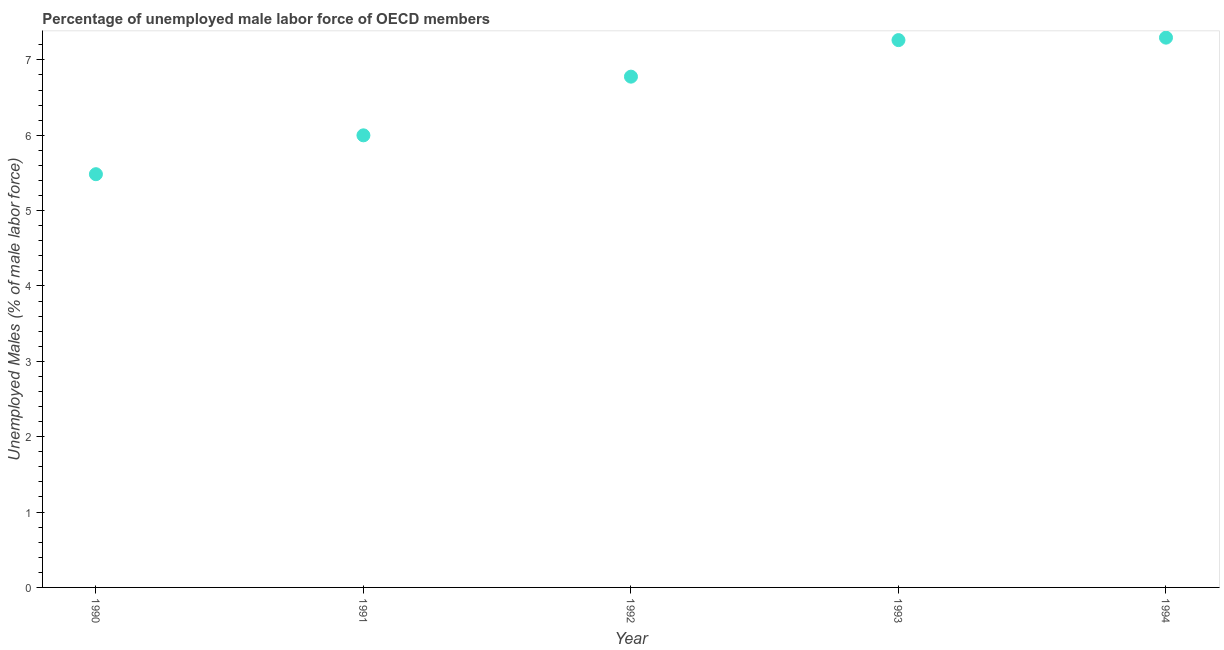What is the total unemployed male labour force in 1992?
Make the answer very short. 6.78. Across all years, what is the maximum total unemployed male labour force?
Offer a very short reply. 7.3. Across all years, what is the minimum total unemployed male labour force?
Provide a short and direct response. 5.48. In which year was the total unemployed male labour force maximum?
Your response must be concise. 1994. What is the sum of the total unemployed male labour force?
Ensure brevity in your answer.  32.82. What is the difference between the total unemployed male labour force in 1991 and 1992?
Keep it short and to the point. -0.78. What is the average total unemployed male labour force per year?
Keep it short and to the point. 6.56. What is the median total unemployed male labour force?
Your answer should be compact. 6.78. In how many years, is the total unemployed male labour force greater than 1 %?
Your response must be concise. 5. What is the ratio of the total unemployed male labour force in 1993 to that in 1994?
Give a very brief answer. 1. Is the total unemployed male labour force in 1992 less than that in 1993?
Provide a succinct answer. Yes. What is the difference between the highest and the second highest total unemployed male labour force?
Keep it short and to the point. 0.03. What is the difference between the highest and the lowest total unemployed male labour force?
Ensure brevity in your answer.  1.81. In how many years, is the total unemployed male labour force greater than the average total unemployed male labour force taken over all years?
Offer a terse response. 3. Does the total unemployed male labour force monotonically increase over the years?
Your answer should be compact. Yes. What is the difference between two consecutive major ticks on the Y-axis?
Keep it short and to the point. 1. What is the title of the graph?
Provide a succinct answer. Percentage of unemployed male labor force of OECD members. What is the label or title of the X-axis?
Your answer should be very brief. Year. What is the label or title of the Y-axis?
Your answer should be compact. Unemployed Males (% of male labor force). What is the Unemployed Males (% of male labor force) in 1990?
Your answer should be very brief. 5.48. What is the Unemployed Males (% of male labor force) in 1991?
Keep it short and to the point. 6. What is the Unemployed Males (% of male labor force) in 1992?
Keep it short and to the point. 6.78. What is the Unemployed Males (% of male labor force) in 1993?
Offer a terse response. 7.26. What is the Unemployed Males (% of male labor force) in 1994?
Ensure brevity in your answer.  7.3. What is the difference between the Unemployed Males (% of male labor force) in 1990 and 1991?
Provide a succinct answer. -0.52. What is the difference between the Unemployed Males (% of male labor force) in 1990 and 1992?
Your answer should be compact. -1.29. What is the difference between the Unemployed Males (% of male labor force) in 1990 and 1993?
Make the answer very short. -1.78. What is the difference between the Unemployed Males (% of male labor force) in 1990 and 1994?
Keep it short and to the point. -1.81. What is the difference between the Unemployed Males (% of male labor force) in 1991 and 1992?
Offer a very short reply. -0.78. What is the difference between the Unemployed Males (% of male labor force) in 1991 and 1993?
Give a very brief answer. -1.26. What is the difference between the Unemployed Males (% of male labor force) in 1991 and 1994?
Your answer should be very brief. -1.3. What is the difference between the Unemployed Males (% of male labor force) in 1992 and 1993?
Ensure brevity in your answer.  -0.48. What is the difference between the Unemployed Males (% of male labor force) in 1992 and 1994?
Your answer should be compact. -0.52. What is the difference between the Unemployed Males (% of male labor force) in 1993 and 1994?
Offer a terse response. -0.03. What is the ratio of the Unemployed Males (% of male labor force) in 1990 to that in 1991?
Your answer should be compact. 0.91. What is the ratio of the Unemployed Males (% of male labor force) in 1990 to that in 1992?
Offer a very short reply. 0.81. What is the ratio of the Unemployed Males (% of male labor force) in 1990 to that in 1993?
Your response must be concise. 0.76. What is the ratio of the Unemployed Males (% of male labor force) in 1990 to that in 1994?
Provide a succinct answer. 0.75. What is the ratio of the Unemployed Males (% of male labor force) in 1991 to that in 1992?
Offer a terse response. 0.89. What is the ratio of the Unemployed Males (% of male labor force) in 1991 to that in 1993?
Your answer should be compact. 0.83. What is the ratio of the Unemployed Males (% of male labor force) in 1991 to that in 1994?
Give a very brief answer. 0.82. What is the ratio of the Unemployed Males (% of male labor force) in 1992 to that in 1993?
Offer a very short reply. 0.93. What is the ratio of the Unemployed Males (% of male labor force) in 1992 to that in 1994?
Make the answer very short. 0.93. 